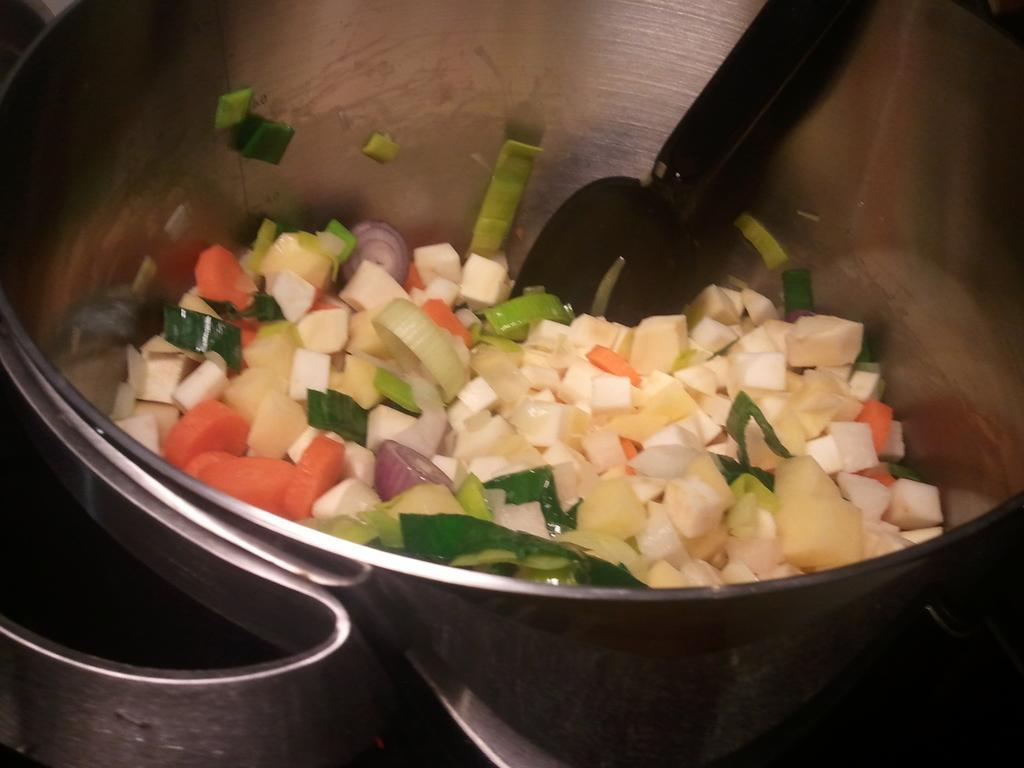What type of food can be seen in the image? There is food in the image, but the specific type cannot be determined from the facts provided. What utensil is present in the image? There is a spoon in the image. What is the spoon placed in? The spoon is in a steel bowl. What type of flame can be seen in the image? There is no flame present in the image. Can you tell me how many books are in the library depicted in the image? There is no library depicted in the image. 